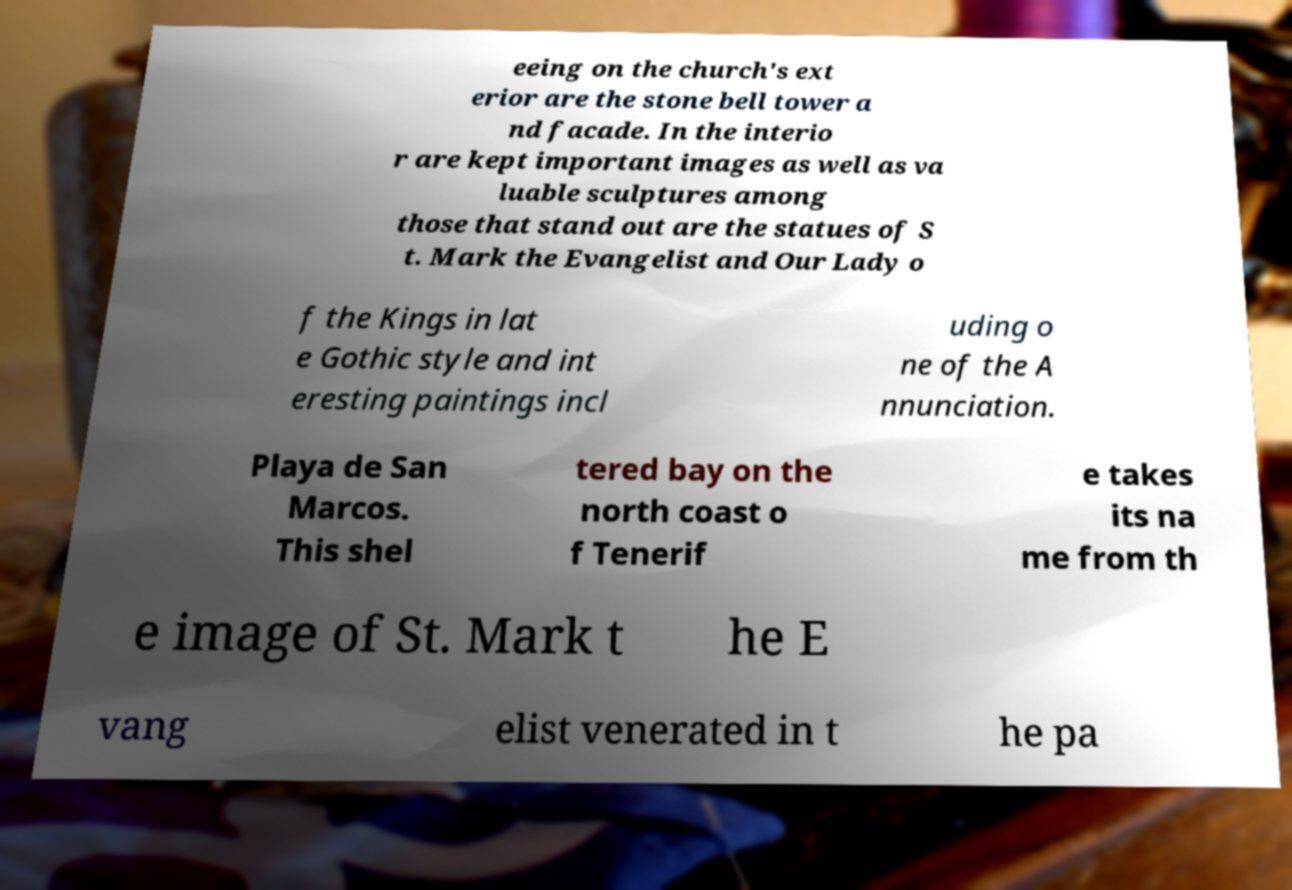Please identify and transcribe the text found in this image. eeing on the church's ext erior are the stone bell tower a nd facade. In the interio r are kept important images as well as va luable sculptures among those that stand out are the statues of S t. Mark the Evangelist and Our Lady o f the Kings in lat e Gothic style and int eresting paintings incl uding o ne of the A nnunciation. Playa de San Marcos. This shel tered bay on the north coast o f Tenerif e takes its na me from th e image of St. Mark t he E vang elist venerated in t he pa 